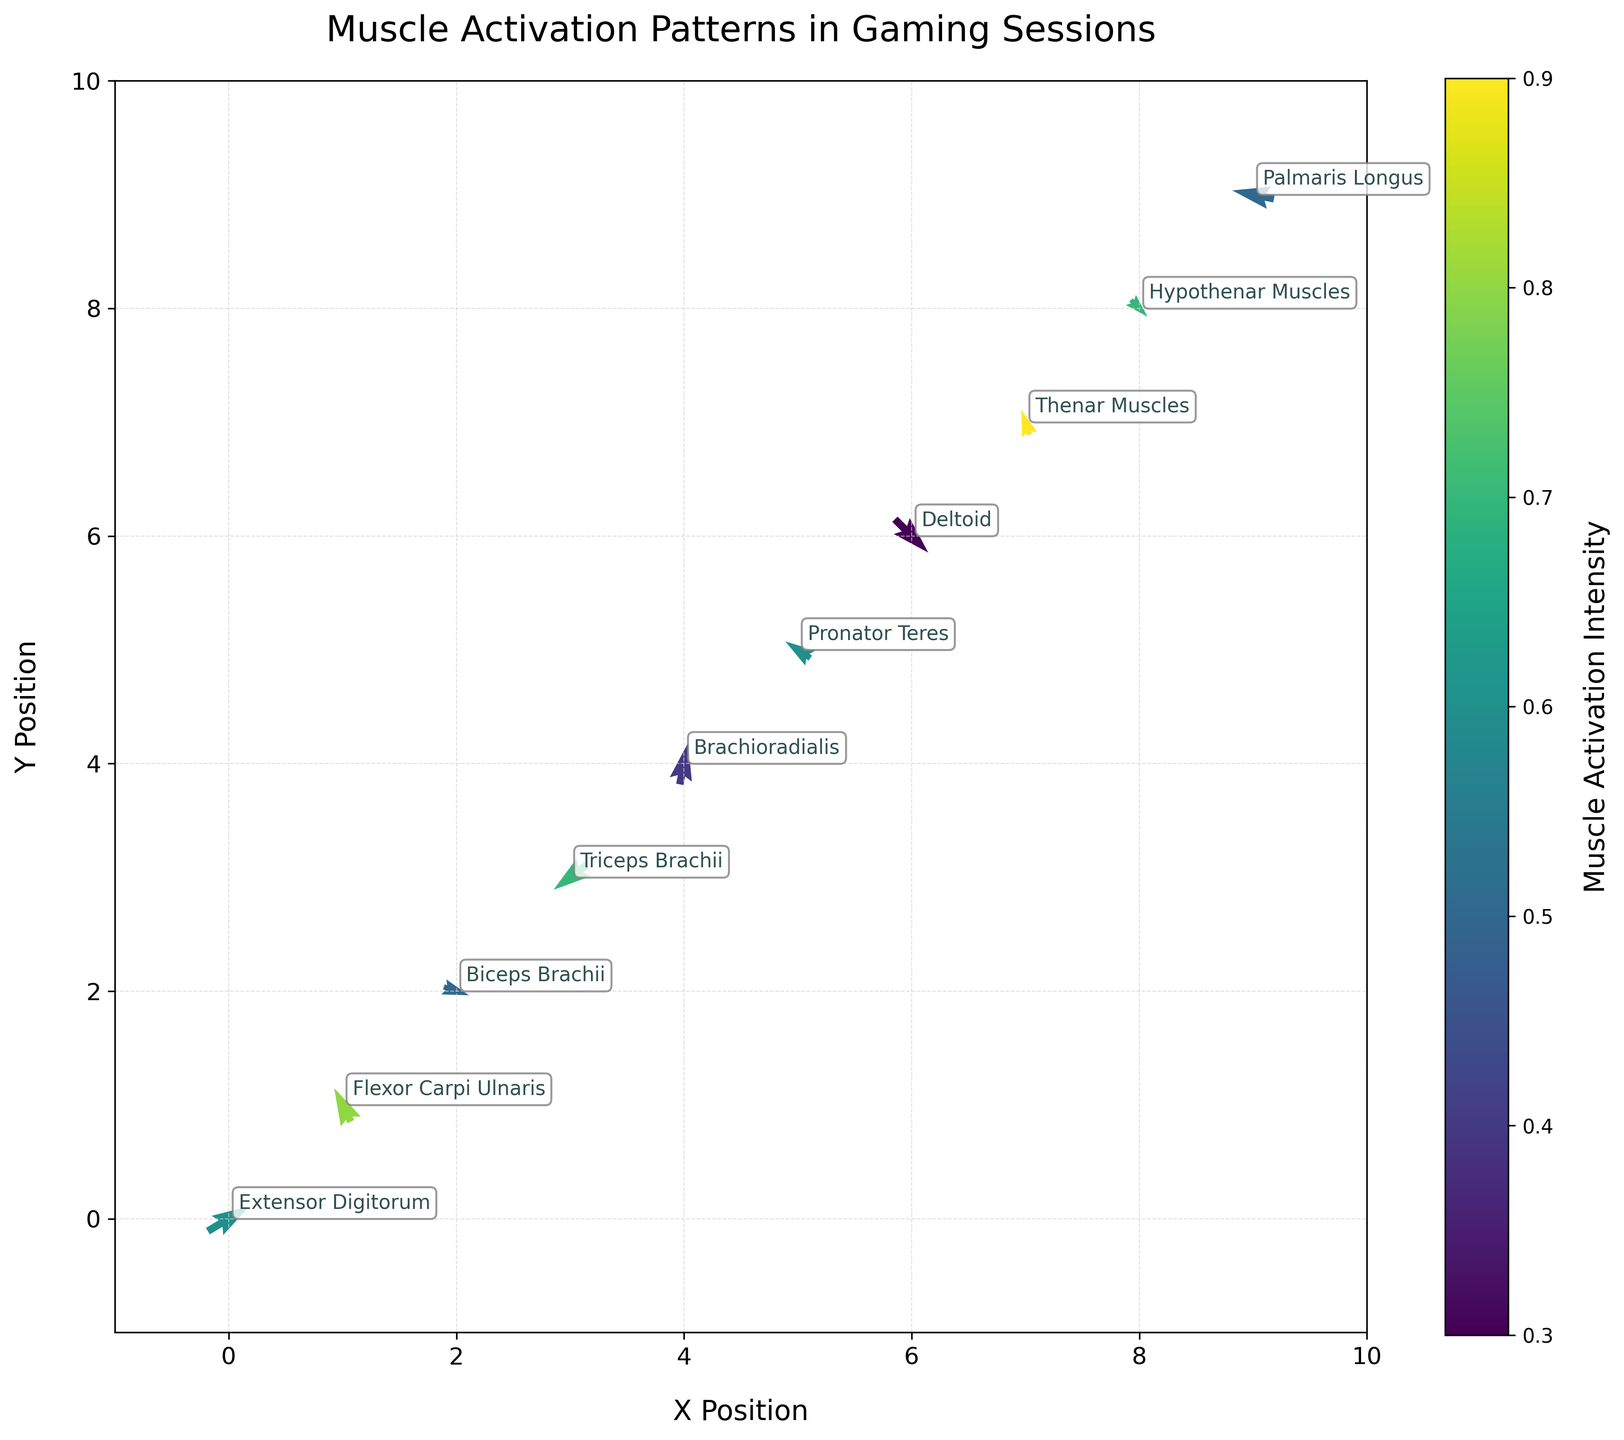What is the title of the plot? The title of the plot is usually located at the top of the figure and helps viewers understand the main topic being represented. The title of this plot is "Muscle Activation Patterns in Gaming Sessions".
Answer: Muscle Activation Patterns in Gaming Sessions How many muscle groups are shown in the figure? Each muscle group is represented by a labeled point in the plot. By counting the labels, we can determine the total number of muscle groups.
Answer: 10 Which muscle group has the highest activation intensity? The color intensity on the plot corresponds to the muscle activation intensity. By observing the color scale and the labels, we can determine that "Thenar Muscles" have the highest intensity, as they are represented with the darkest color.
Answer: Thenar Muscles Where is the Extensor Digitorum muscle group located on the plot? The location on the plot is defined by the (x, y) coordinates, which can be identified from the label "Extensor Digitorum". It is located at (0, 0).
Answer: (0, 0) What are the directions of the vectors representing the Deltoid and Biceps Brachii muscle groups? The directions of the vectors can be determined by their (u, v) components. For Deltoid, the vector point is (0.4, -0.4) indicating a northeast-to-southwest direction. For Biceps Brachii, the vector point is (0.3, -0.1) indicating a southwest-to-northeast direction.
Answer: Deltoid: Northeast-to-Southwest, Biceps Brachii: Southwest-to-Northeast Which muscle group has almost no horizontal movement, and what is its vertical component? By checking the (u, v) components, we find that "Flexor Carpi Ulnaris" has a very small horizontal component of -0.2 and a vertical component of 0.4.
Answer: Flexor Carpi Ulnaris, vertical component: 0.4 Which muscle groups exhibit a downward activation direction? Muscle groups with a negative vertical component will exhibit downward activation. In the data, "Biceps Brachii", "Triceps Brachii", "Deltoid", and "Hypothenar Muscles" have negative vertical components.
Answer: Biceps Brachii, Triceps Brachii, Deltoid, Hypothenar Muscles Which muscle groups have a positive horizontal movement and what are their intensities? Muscle groups with a positive horizontal component will indicate positive horizontal movement. These include "Extensor Digitorum" (0.6), "Biceps Brachii" (0.5), "Brachioradialis" (0.4), and "Deltoid" (0.3).
Answer: Extensor Digitorum: 0.6, Biceps Brachii: 0.5, Brachioradialis: 0.4, Deltoid: 0.3 Compare the muscle activation intensity between Flexor Carpi Ulnaris and Deltoid. Which one is greater? By comparing their color intensities and activation values, "Flexor Carpi Ulnaris" has an intensity of 0.8, which is greater than "Deltoid", which has an intensity of 0.3.
Answer: Flexor Carpi Ulnaris is greater Which muscle group lies furthest to the right, and what is its intensity? The x-coordinate indicates the horizontal position. "Palmaris Longus" lies at (9, 9), the furthest to the right, with an intensity of 0.5.
Answer: Palmaris Longus, intensity: 0.5 